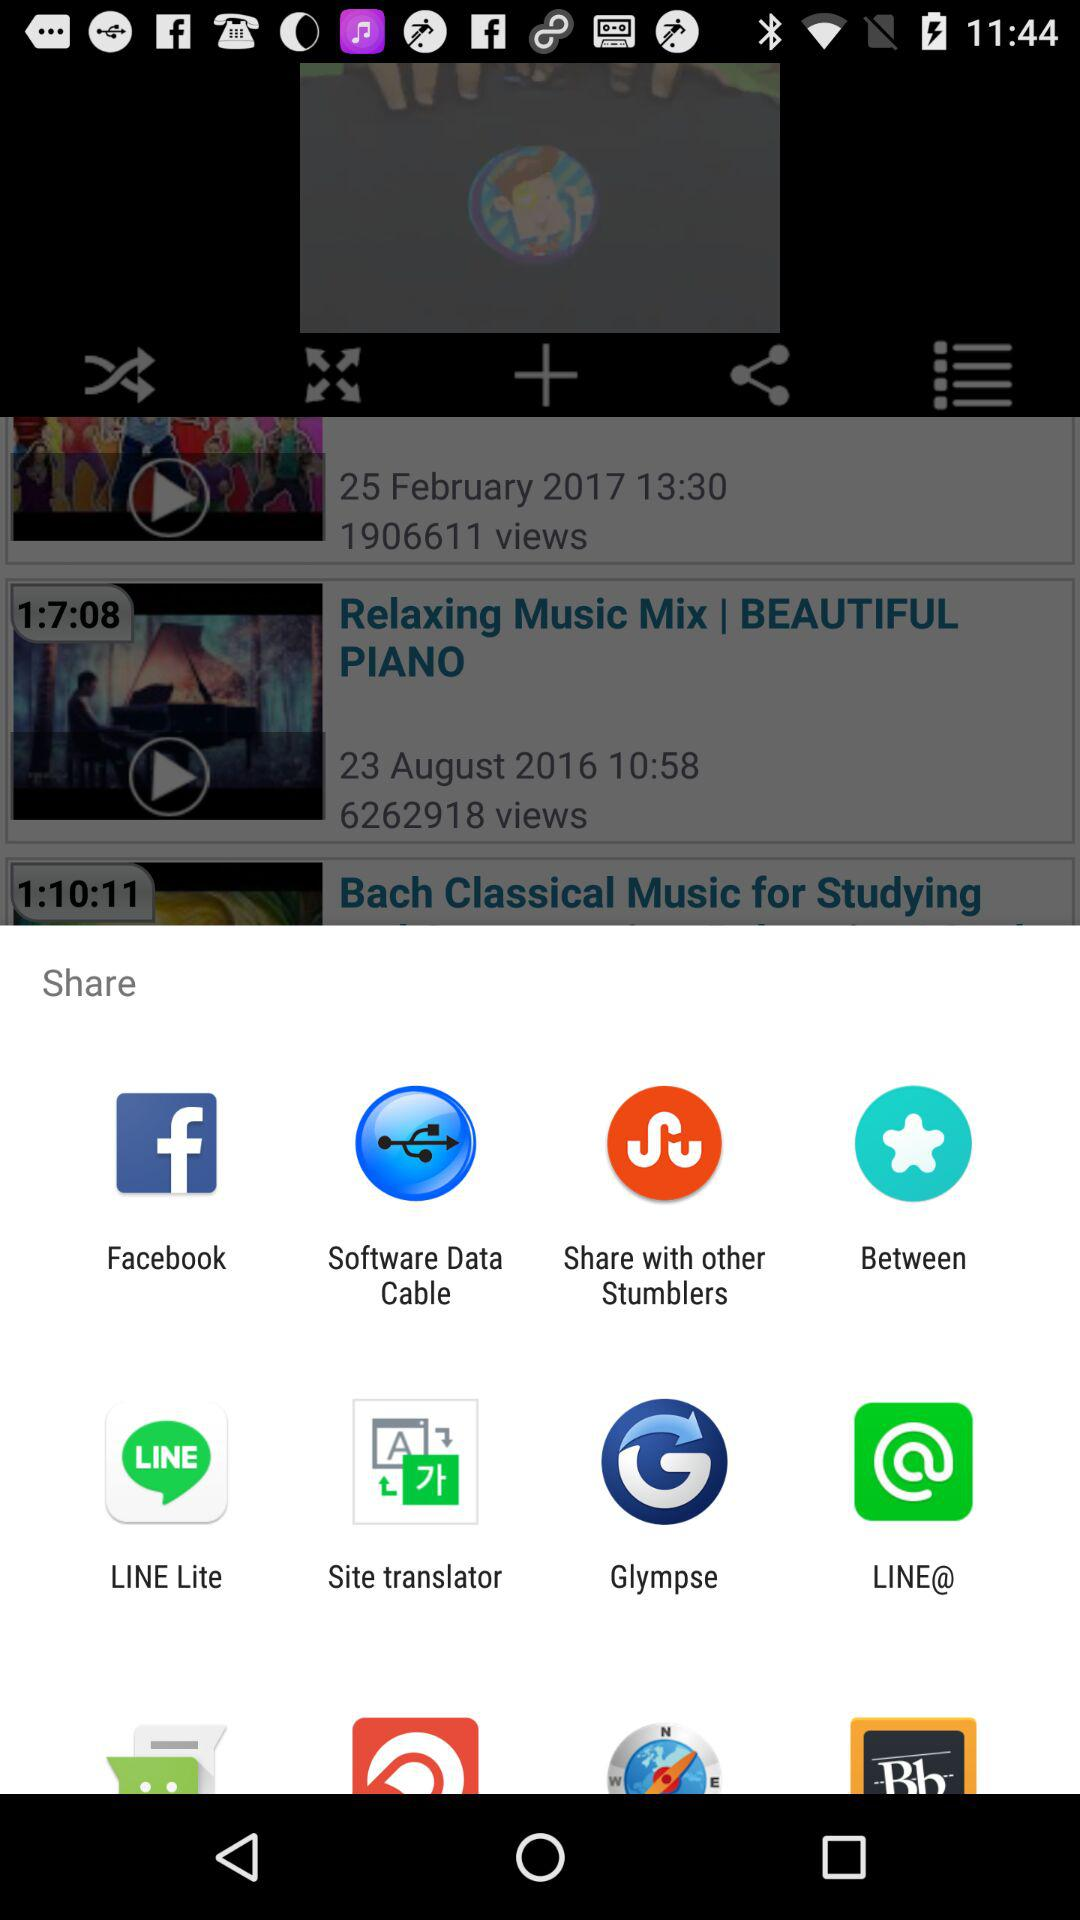What are the different applications through which we can share? The different applications to share are "Facebook", "Software Data Cable", "Share with other Stumblers", "Between", "LINE Lite", "Site translator", "Glympse" and "LINE@". 